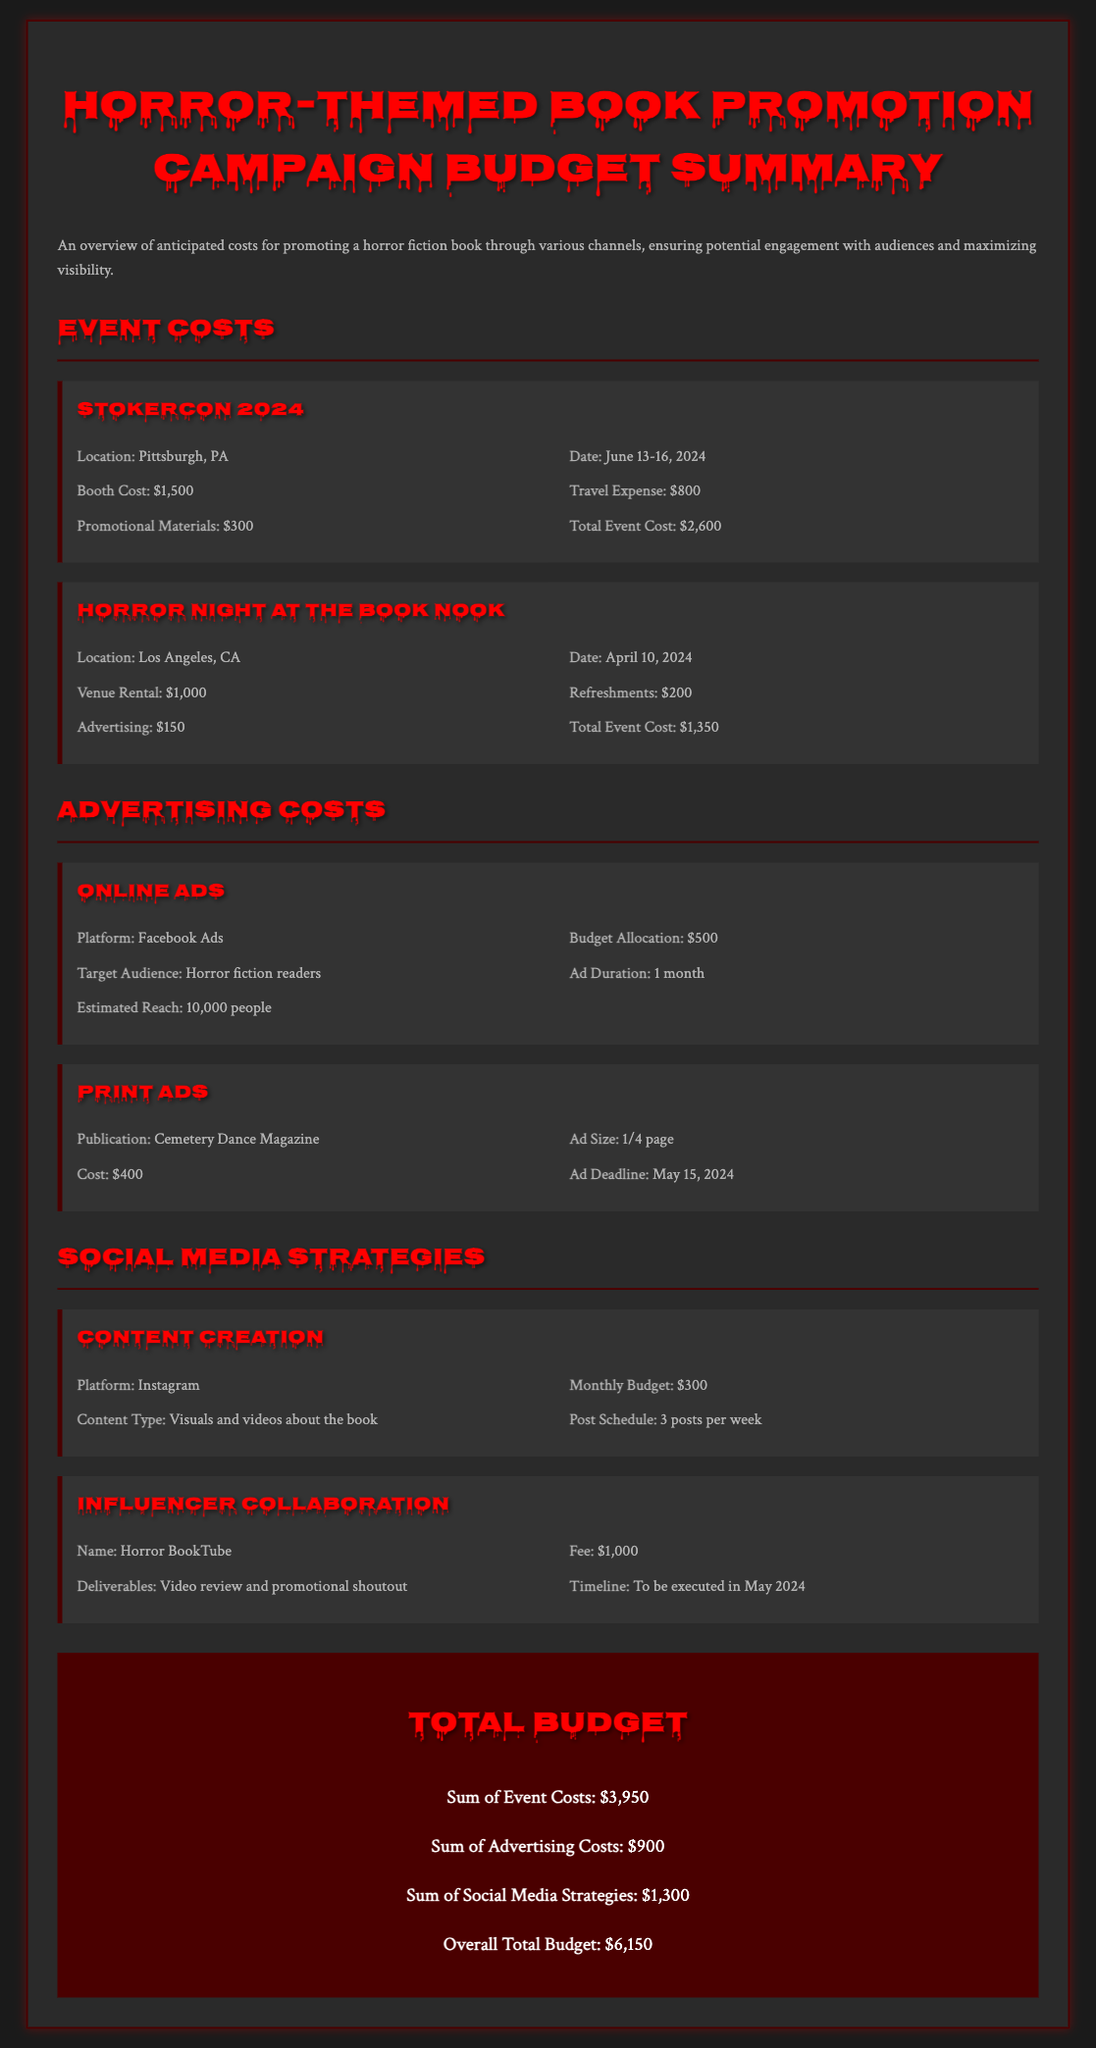what is the total event cost for StokerCon 2024? The total event cost for StokerCon 2024 is stated directly in the document as $2,600.
Answer: $2,600 what is the advertising budget allocation for Online Ads? The document specifies the budget allocation for Online Ads as $500.
Answer: $500 what is the location for Horror Night at The Book Nook? The location for Horror Night at The Book Nook is indicated as Los Angeles, CA.
Answer: Los Angeles, CA how much is the fee for the Influencer Collaboration? The fee for the Influencer Collaboration is listed in the document as $1,000.
Answer: $1,000 what is the estimated reach for Facebook Ads? According to the document, the estimated reach for Facebook Ads is 10,000 people.
Answer: 10,000 people what is the sum of advertising costs? The sum of advertising costs is calculated and presented in the document as $900.
Answer: $900 what type of content is planned for Instagram? The document describes the content type for Instagram as visuals and videos about the book.
Answer: Visuals and videos about the book which event has the highest total cost? The events are compared in the document, revealing that StokerCon 2024 has the highest total cost of $2,600.
Answer: StokerCon 2024 what is the overall total budget for the campaigns? The overall total budget is summarized in the document as $6,150.
Answer: $6,150 